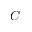Convert formula to latex. <formula><loc_0><loc_0><loc_500><loc_500>C</formula> 